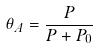Convert formula to latex. <formula><loc_0><loc_0><loc_500><loc_500>\theta _ { A } = \frac { P } { P + P _ { 0 } }</formula> 